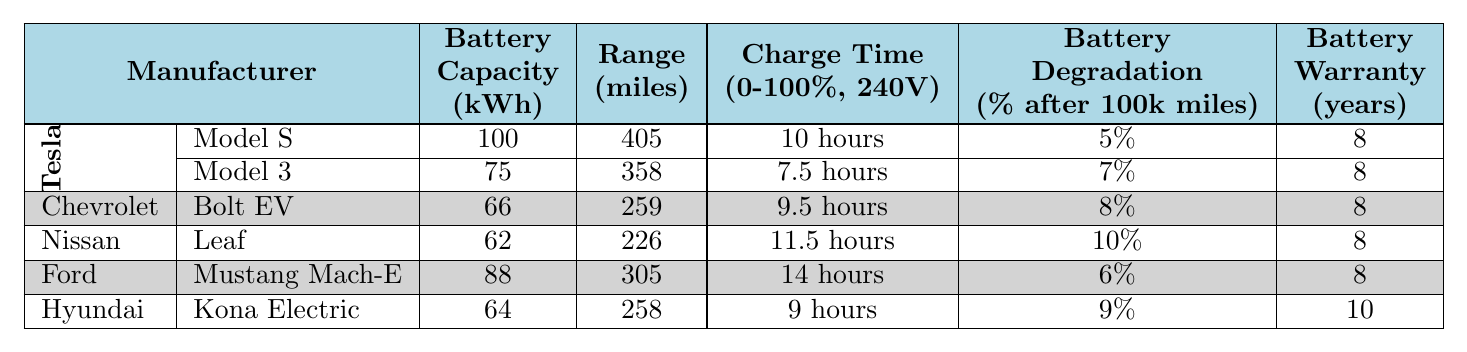What is the battery capacity of the Tesla Model S? The battery capacity of the Tesla Model S is listed as 100 kWh in the table.
Answer: 100 kWh Which vehicle has the longest range? The longest range is indicated for the Tesla Model S, which has a range of 405 miles.
Answer: Tesla Model S How many manufacturers in the table provide a warranty of 10 years? Only Hyundai with the Kona Electric provides a warranty of 10 years. This can be determined by checking the warranty years for each vehicle listed.
Answer: 1 What is the average battery degradation percentage for Chevrolet and Nissan vehicles? The Chevrolet Bolt EV has a degradation of 8%, and the Nissan Leaf has 10%. The average is (8 + 10) / 2 = 9%.
Answer: 9% Is the Ford Mustang Mach-E's charge time longer than Tesla Model 3's charge time? The charge time for Ford Mustang Mach-E is 14 hours, while that for Tesla Model 3 is 7.5 hours, making the Ford's charge time longer.
Answer: Yes What is the total battery capacity of all the electric vehicles listed in the table? The capacities of all vehicles are: Tesla Model S (100 kWh), Tesla Model 3 (75 kWh), Chevrolet Bolt EV (66 kWh), Nissan Leaf (62 kWh), Ford Mustang Mach-E (88 kWh), and Hyundai Kona Electric (64 kWh). Summing these gives 100 + 75 + 66 + 62 + 88 + 64 = 455 kWh.
Answer: 455 kWh How does the range of the Hyundai Kona Electric compare to the range of the Nissan Leaf? The range of Hyundai Kona Electric is 258 miles, while Nissan Leaf has a range of 226 miles. Comparing these numbers shows that the Kona Electric has a longer range than the Leaf by 258 - 226 = 32 miles.
Answer: Hyundai Kona Electric has a longer range Which vehicle has the shortest charge time? The shortest charge time is noted for the Tesla Model 3 at 7.5 hours, which is less than that of any other vehicle in the table.
Answer: Tesla Model 3 What are the degradation percentages for Tesla vehicles combined? The battery degradation for the Tesla Model S is 5% and for Model 3 is 7%. Combined, the percentage calculations give a total of (5 + 7) = 12%. To find the average, you would take 12 / 2 = 6%.
Answer: 6% Does the Chevrolet Bolt EV have better battery capacity compared to the Nissan Leaf? The battery capacity of Chevrolet Bolt EV is 66 kWh while that of Nissan Leaf is 62 kWh, meaning the Bolt EV has a higher capacity.
Answer: Yes 